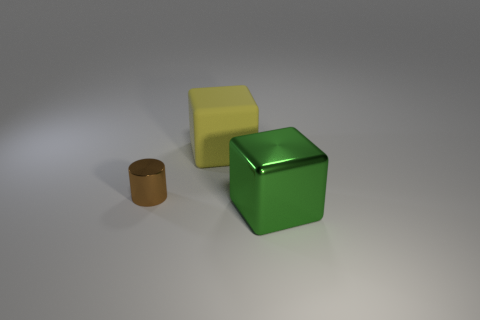Subtract all yellow blocks. How many blocks are left? 1 Add 3 big yellow rubber cubes. How many objects exist? 6 Subtract all tiny brown metal things. Subtract all yellow blocks. How many objects are left? 1 Add 2 shiny objects. How many shiny objects are left? 4 Add 3 gray cylinders. How many gray cylinders exist? 3 Subtract 0 blue cylinders. How many objects are left? 3 Subtract all cubes. How many objects are left? 1 Subtract all cyan cubes. Subtract all blue spheres. How many cubes are left? 2 Subtract all cyan balls. How many green cubes are left? 1 